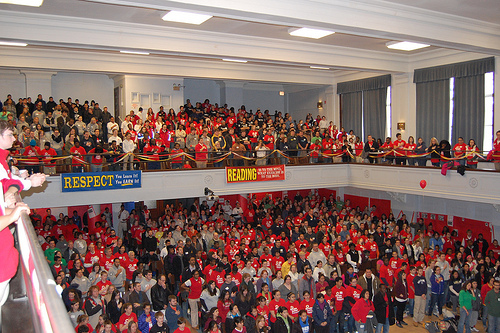<image>
Can you confirm if the banner is to the left of the balloon? Yes. From this viewpoint, the banner is positioned to the left side relative to the balloon. 